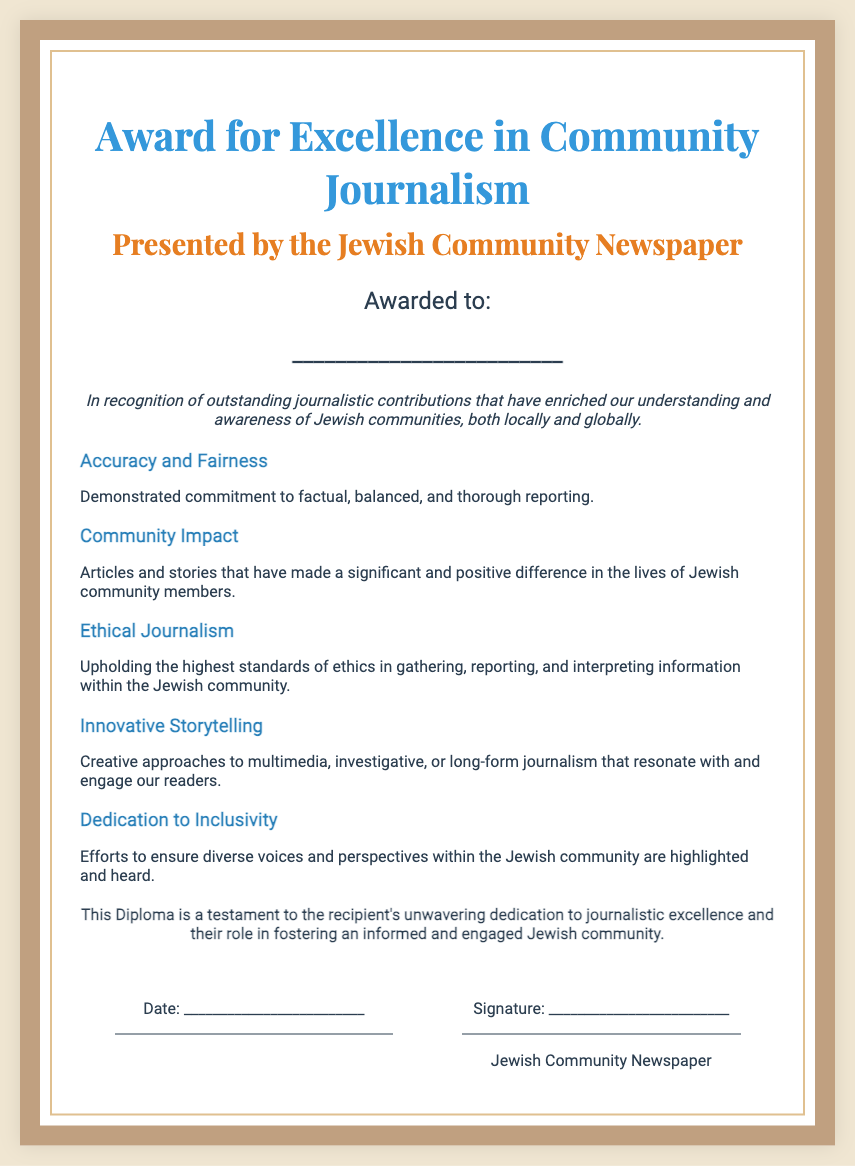What is the title of the award? The title of the award is the prominent heading of the document.
Answer: Award for Excellence in Community Journalism Who presents the award? The presenting organization is specified right below the title in the document.
Answer: Jewish Community Newspaper What is awarded to the recipient? The document states the purpose of the diploma immediately after the recipient section.
Answer: Outstanding journalistic contributions What are one of the criteria for the award? The criteria listed in the document detail the standards for receiving the award.
Answer: Accuracy and Fairness What is one aspect of Ethical Journalism mentioned? The document highlights the standards upheld within the criteria section related to ethics.
Answer: Highest standards of ethics What type of contribution does the award recognize? The introduction outlines the type of contributions being recognized through the award.
Answer: Journalistic contributions What does the conclusion say about the recipient? The conclusion summarizes the significance of the award to the recipient.
Answer: Testament to the recipient's unwavering dedication What is the spacing style used for the signature line? The signature line's style is described as appearing in a specific way within the document.
Answer: Border-top style What is the recipient's information placeholder? The placeholder for the recipient is shown in the award section.
Answer: _________________________ What does the date section represent? The date section indicates what the area below the award is intended for.
Answer: Date of the award presentation 